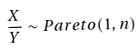<formula> <loc_0><loc_0><loc_500><loc_500>\frac { X } { Y } \sim P a r e t o ( 1 , n )</formula> 